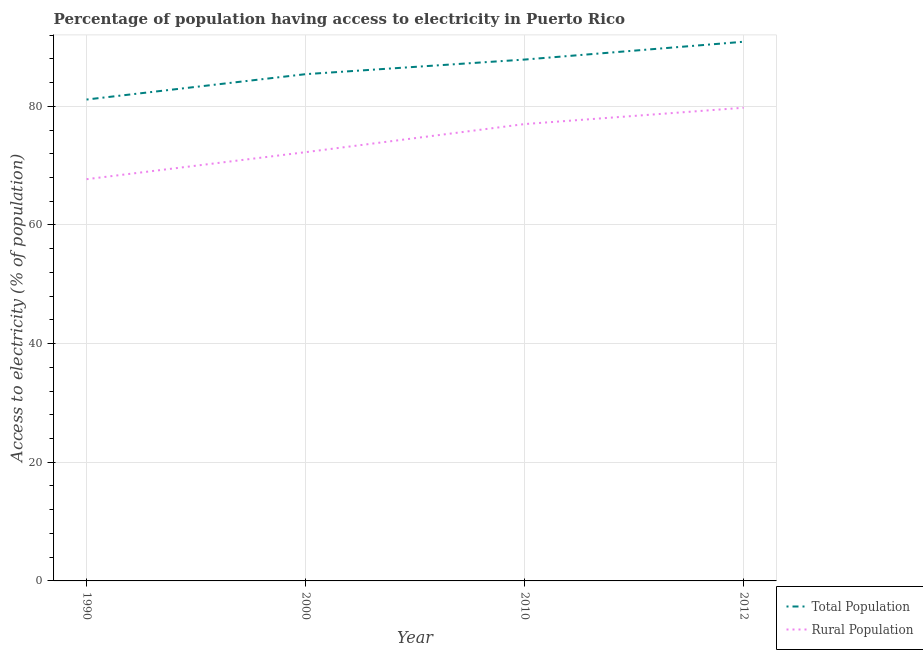Does the line corresponding to percentage of population having access to electricity intersect with the line corresponding to percentage of rural population having access to electricity?
Provide a succinct answer. No. Is the number of lines equal to the number of legend labels?
Give a very brief answer. Yes. What is the percentage of population having access to electricity in 2012?
Provide a short and direct response. 90.88. Across all years, what is the maximum percentage of rural population having access to electricity?
Make the answer very short. 79.75. Across all years, what is the minimum percentage of rural population having access to electricity?
Keep it short and to the point. 67.71. What is the total percentage of rural population having access to electricity in the graph?
Your answer should be compact. 296.73. What is the difference between the percentage of population having access to electricity in 2000 and that in 2010?
Provide a short and direct response. -2.46. What is the difference between the percentage of rural population having access to electricity in 1990 and the percentage of population having access to electricity in 2000?
Give a very brief answer. -17.7. What is the average percentage of population having access to electricity per year?
Offer a terse response. 86.32. In the year 1990, what is the difference between the percentage of rural population having access to electricity and percentage of population having access to electricity?
Ensure brevity in your answer.  -13.42. In how many years, is the percentage of population having access to electricity greater than 64 %?
Ensure brevity in your answer.  4. What is the ratio of the percentage of population having access to electricity in 2010 to that in 2012?
Provide a succinct answer. 0.97. What is the difference between the highest and the second highest percentage of rural population having access to electricity?
Your answer should be compact. 2.75. What is the difference between the highest and the lowest percentage of rural population having access to electricity?
Your answer should be compact. 12.04. Is the sum of the percentage of population having access to electricity in 1990 and 2000 greater than the maximum percentage of rural population having access to electricity across all years?
Provide a succinct answer. Yes. Are the values on the major ticks of Y-axis written in scientific E-notation?
Ensure brevity in your answer.  No. Does the graph contain grids?
Offer a very short reply. Yes. How many legend labels are there?
Offer a terse response. 2. What is the title of the graph?
Offer a terse response. Percentage of population having access to electricity in Puerto Rico. What is the label or title of the Y-axis?
Provide a succinct answer. Access to electricity (% of population). What is the Access to electricity (% of population) of Total Population in 1990?
Your response must be concise. 81.14. What is the Access to electricity (% of population) in Rural Population in 1990?
Ensure brevity in your answer.  67.71. What is the Access to electricity (% of population) in Total Population in 2000?
Offer a very short reply. 85.41. What is the Access to electricity (% of population) of Rural Population in 2000?
Provide a succinct answer. 72.27. What is the Access to electricity (% of population) of Total Population in 2010?
Provide a succinct answer. 87.87. What is the Access to electricity (% of population) in Rural Population in 2010?
Give a very brief answer. 77. What is the Access to electricity (% of population) of Total Population in 2012?
Provide a succinct answer. 90.88. What is the Access to electricity (% of population) of Rural Population in 2012?
Offer a very short reply. 79.75. Across all years, what is the maximum Access to electricity (% of population) in Total Population?
Provide a succinct answer. 90.88. Across all years, what is the maximum Access to electricity (% of population) in Rural Population?
Offer a very short reply. 79.75. Across all years, what is the minimum Access to electricity (% of population) in Total Population?
Provide a succinct answer. 81.14. Across all years, what is the minimum Access to electricity (% of population) in Rural Population?
Offer a very short reply. 67.71. What is the total Access to electricity (% of population) of Total Population in the graph?
Keep it short and to the point. 345.3. What is the total Access to electricity (% of population) of Rural Population in the graph?
Offer a terse response. 296.73. What is the difference between the Access to electricity (% of population) of Total Population in 1990 and that in 2000?
Give a very brief answer. -4.28. What is the difference between the Access to electricity (% of population) in Rural Population in 1990 and that in 2000?
Offer a terse response. -4.55. What is the difference between the Access to electricity (% of population) in Total Population in 1990 and that in 2010?
Ensure brevity in your answer.  -6.74. What is the difference between the Access to electricity (% of population) of Rural Population in 1990 and that in 2010?
Provide a short and direct response. -9.29. What is the difference between the Access to electricity (% of population) in Total Population in 1990 and that in 2012?
Give a very brief answer. -9.74. What is the difference between the Access to electricity (% of population) in Rural Population in 1990 and that in 2012?
Ensure brevity in your answer.  -12.04. What is the difference between the Access to electricity (% of population) in Total Population in 2000 and that in 2010?
Give a very brief answer. -2.46. What is the difference between the Access to electricity (% of population) of Rural Population in 2000 and that in 2010?
Offer a very short reply. -4.74. What is the difference between the Access to electricity (% of population) in Total Population in 2000 and that in 2012?
Your answer should be compact. -5.46. What is the difference between the Access to electricity (% of population) in Rural Population in 2000 and that in 2012?
Provide a succinct answer. -7.49. What is the difference between the Access to electricity (% of population) of Total Population in 2010 and that in 2012?
Ensure brevity in your answer.  -3. What is the difference between the Access to electricity (% of population) in Rural Population in 2010 and that in 2012?
Offer a terse response. -2.75. What is the difference between the Access to electricity (% of population) in Total Population in 1990 and the Access to electricity (% of population) in Rural Population in 2000?
Offer a very short reply. 8.87. What is the difference between the Access to electricity (% of population) in Total Population in 1990 and the Access to electricity (% of population) in Rural Population in 2010?
Ensure brevity in your answer.  4.14. What is the difference between the Access to electricity (% of population) of Total Population in 1990 and the Access to electricity (% of population) of Rural Population in 2012?
Offer a very short reply. 1.38. What is the difference between the Access to electricity (% of population) of Total Population in 2000 and the Access to electricity (% of population) of Rural Population in 2010?
Make the answer very short. 8.41. What is the difference between the Access to electricity (% of population) of Total Population in 2000 and the Access to electricity (% of population) of Rural Population in 2012?
Keep it short and to the point. 5.66. What is the difference between the Access to electricity (% of population) in Total Population in 2010 and the Access to electricity (% of population) in Rural Population in 2012?
Give a very brief answer. 8.12. What is the average Access to electricity (% of population) of Total Population per year?
Your answer should be very brief. 86.32. What is the average Access to electricity (% of population) in Rural Population per year?
Your answer should be very brief. 74.18. In the year 1990, what is the difference between the Access to electricity (% of population) of Total Population and Access to electricity (% of population) of Rural Population?
Keep it short and to the point. 13.42. In the year 2000, what is the difference between the Access to electricity (% of population) in Total Population and Access to electricity (% of population) in Rural Population?
Offer a terse response. 13.15. In the year 2010, what is the difference between the Access to electricity (% of population) in Total Population and Access to electricity (% of population) in Rural Population?
Your response must be concise. 10.87. In the year 2012, what is the difference between the Access to electricity (% of population) of Total Population and Access to electricity (% of population) of Rural Population?
Offer a very short reply. 11.12. What is the ratio of the Access to electricity (% of population) of Total Population in 1990 to that in 2000?
Keep it short and to the point. 0.95. What is the ratio of the Access to electricity (% of population) of Rural Population in 1990 to that in 2000?
Your response must be concise. 0.94. What is the ratio of the Access to electricity (% of population) in Total Population in 1990 to that in 2010?
Ensure brevity in your answer.  0.92. What is the ratio of the Access to electricity (% of population) in Rural Population in 1990 to that in 2010?
Provide a short and direct response. 0.88. What is the ratio of the Access to electricity (% of population) in Total Population in 1990 to that in 2012?
Offer a terse response. 0.89. What is the ratio of the Access to electricity (% of population) of Rural Population in 1990 to that in 2012?
Offer a very short reply. 0.85. What is the ratio of the Access to electricity (% of population) of Total Population in 2000 to that in 2010?
Offer a very short reply. 0.97. What is the ratio of the Access to electricity (% of population) in Rural Population in 2000 to that in 2010?
Ensure brevity in your answer.  0.94. What is the ratio of the Access to electricity (% of population) of Total Population in 2000 to that in 2012?
Your answer should be compact. 0.94. What is the ratio of the Access to electricity (% of population) in Rural Population in 2000 to that in 2012?
Your answer should be compact. 0.91. What is the ratio of the Access to electricity (% of population) of Rural Population in 2010 to that in 2012?
Offer a very short reply. 0.97. What is the difference between the highest and the second highest Access to electricity (% of population) of Total Population?
Offer a very short reply. 3. What is the difference between the highest and the second highest Access to electricity (% of population) of Rural Population?
Your response must be concise. 2.75. What is the difference between the highest and the lowest Access to electricity (% of population) in Total Population?
Your response must be concise. 9.74. What is the difference between the highest and the lowest Access to electricity (% of population) of Rural Population?
Provide a succinct answer. 12.04. 